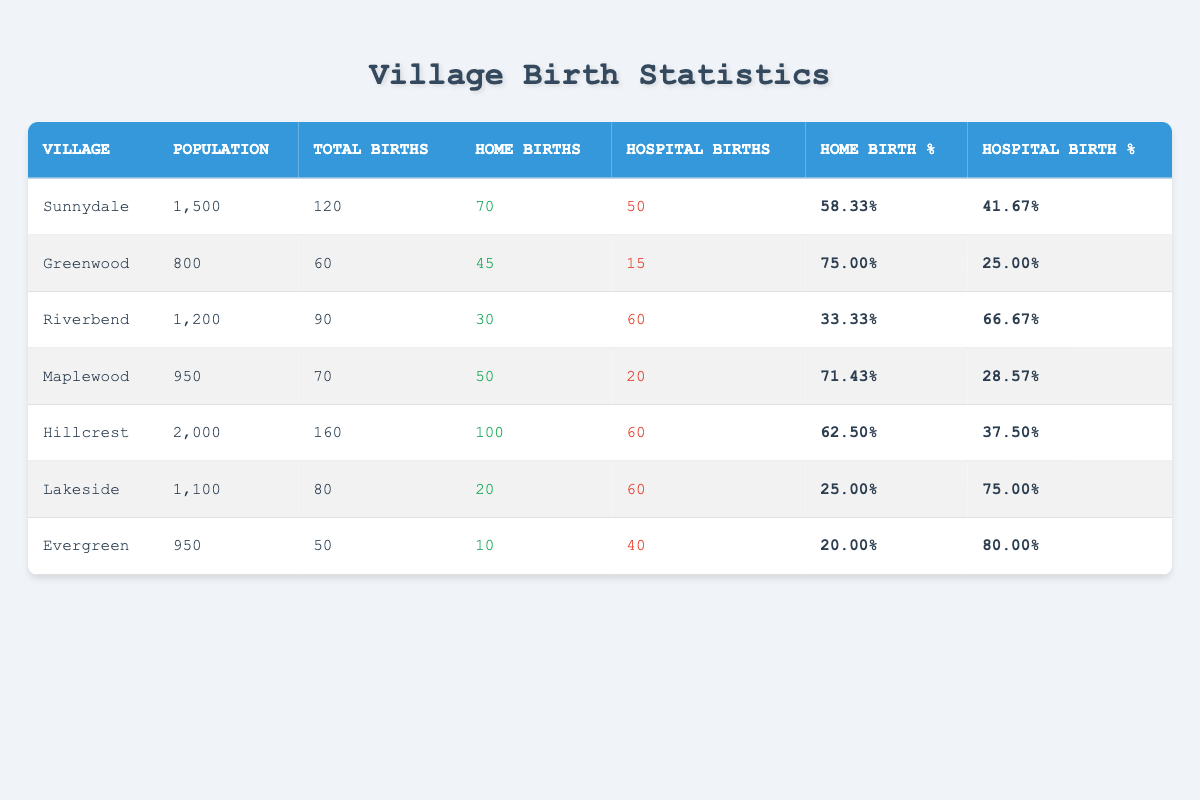What is the total number of births in Sunnydale? In Sunnydale, the column labeled "Total Births" lists 120 as the value. Therefore, this is the total number of births.
Answer: 120 Which village has the highest percentage of home births? Examining the "Home Birth %" column, Greenwood has the highest percentage at 75.00%.
Answer: Greenwood How many more hospital births were there than home births in Riverbend? In Riverbend, there were 60 hospital births and 30 home births. The difference is calculated as 60 - 30 = 30.
Answer: 30 Is the percentage of hospital births in Lakeside greater than that in Maplewood? Lakeside has a hospital birth percentage of 75.00%, while Maplewood has 28.57%. Thus, 75.00% > 28.57%, confirming that Lakeside has a higher percentage.
Answer: Yes What is the average percentage of home births across all villages? To find the average percentage of home births, you sum the home birth percentages of all villages: (58.33 + 75.00 + 33.33 + 71.43 + 62.50 + 25.00 + 20.00) = 345.59. Then, divide by the number of villages (7): 345.59 / 7 ≈ 49.37.
Answer: 49.37 How many total home births were recorded in all villages? By summing the "Home Births" for all villages: 70 + 45 + 30 + 50 + 100 + 20 + 10 = 325. This total represents all home births across the villages.
Answer: 325 Which village has the lowest number of total births? Looking at the "Total Births" column, Evergreen has the lowest count at 50 total births.
Answer: Evergreen Is it true that Hillcrest has more total births than the average of all villages? First, calculate the average total births: (120 + 60 + 90 + 70 + 160 + 80 + 50) = 630 / 7 ≈ 90. Hillcrest has 160 total births, which is greater than the average.
Answer: Yes What percentage of total births in the village with the highest births is accounted for by hospital births? Hillcrest has the highest total births at 160 and 60 hospital births. To find the percentage, calculate (60 / 160) * 100 = 37.50%.
Answer: 37.50% 